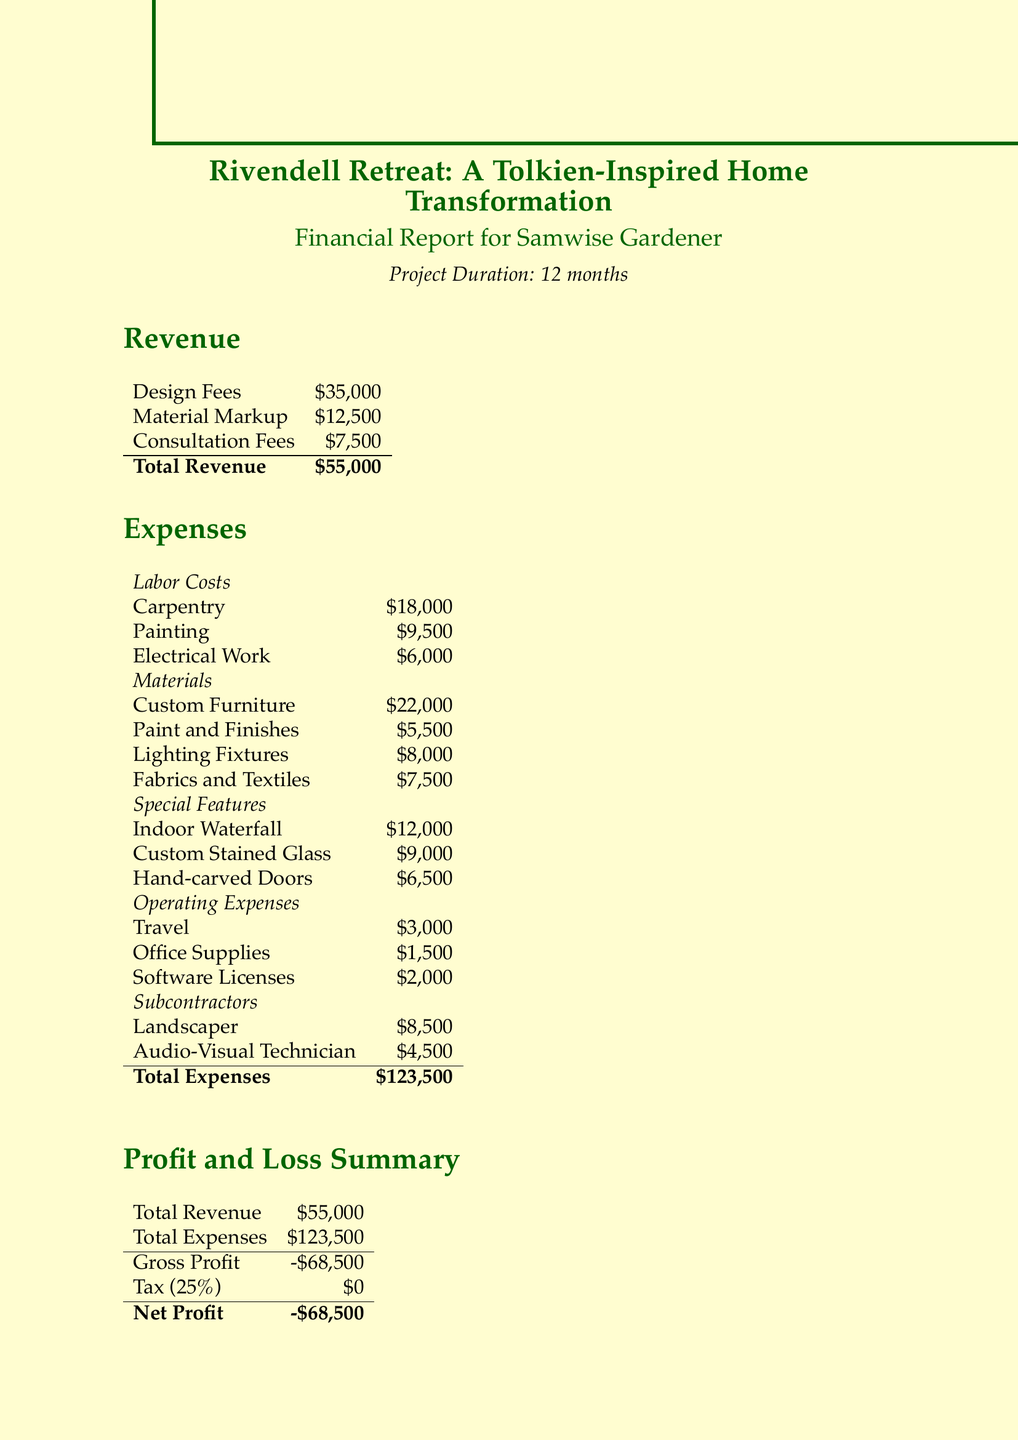What is the project name? The project name, as stated at the beginning of the document, is "Rivendell Retreat: A Tolkien-Inspired Home Transformation."
Answer: Rivendell Retreat: A Tolkien-Inspired Home Transformation Who is the client? The client's name is provided in the financial report as "Samwise Gardener."
Answer: Samwise Gardener What is the total revenue? The total revenue is calculated from design fees, material markup, and consultation fees, giving a total of $55,000.
Answer: $55,000 How much was spent on custom furniture? The document lists custom furniture expenses as $22,000 under materials.
Answer: $22,000 What are the total expenses? The total expenses are summed up as $123,500 according to the expenses section.
Answer: $123,500 What was the gross profit? The gross profit is obtained by subtracting total expenses from total revenue, resulting in -$68,500.
Answer: -$68,500 What is the tax rate mentioned in the report? The tax rate specified in the financial report is 25%.
Answer: 25% What was the net profit for the project? The net profit is recorded as -$68,500, indicating a loss for the project.
Answer: -$68,500 What is the profit margin target? The report mentions a profit margin target of 20%, which was not achieved in this project.
Answer: 20% 